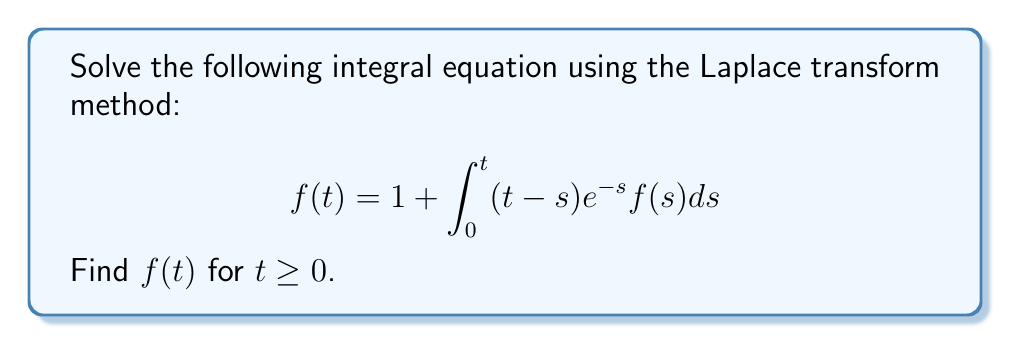What is the answer to this math problem? Let's solve this step-by-step:

1) First, we take the Laplace transform of both sides. Let $F(s)$ be the Laplace transform of $f(t)$.

   $$\mathcal{L}\{f(t)\} = \mathcal{L}\{1\} + \mathcal{L}\{\int_0^t (t-s)e^{-s}f(s)ds\}$$

2) We know that $\mathcal{L}\{1\} = \frac{1}{s}$. For the integral term, we recognize it as a convolution:

   $$F(s) = \frac{1}{s} + \mathcal{L}\{(t-s)e^{-s}\} \cdot F(s)$$

3) We need to find $\mathcal{L}\{(t-s)e^{-s}\}$:
   
   $$\mathcal{L}\{te^{-t}\} = \frac{1}{(s+1)^2}$$
   $$\mathcal{L}\{e^{-t}\} = \frac{1}{s+1}$$
   
   So, $\mathcal{L}\{(t-s)e^{-s}\} = \frac{1}{(s+1)^2} - \frac{1}{(s+1)} = \frac{1}{(s+1)^2} - \frac{1}{s+1}$

4) Substituting this back into our equation:

   $$F(s) = \frac{1}{s} + (\frac{1}{(s+1)^2} - \frac{1}{s+1})F(s)$$

5) Rearranging terms:

   $$F(s)(1 - \frac{1}{(s+1)^2} + \frac{1}{s+1}) = \frac{1}{s}$$

   $$F(s)(\frac{s^2+2s+1-(s+1)+s+1}{(s+1)^2}) = \frac{1}{s}$$

   $$F(s)(\frac{s^2+s+1}{(s+1)^2}) = \frac{1}{s}$$

6) Solving for $F(s)$:

   $$F(s) = \frac{(s+1)^2}{s(s^2+s+1)} = \frac{s^2+2s+1}{s^3+s^2+s}$$

7) This can be decomposed into partial fractions:

   $$F(s) = \frac{1}{s} + \frac{1}{s+1}$$

8) Taking the inverse Laplace transform:

   $$f(t) = 1 + e^{-t}$$
Answer: $f(t) = 1 + e^{-t}$ 